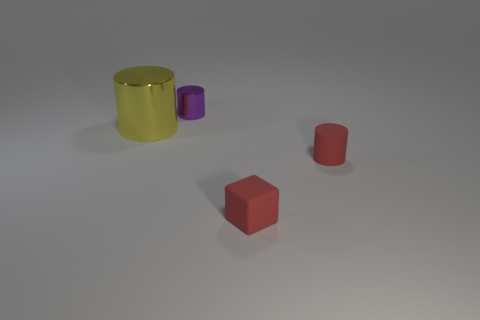Subtract all red rubber cylinders. How many cylinders are left? 2 Add 3 yellow metallic cylinders. How many objects exist? 7 Subtract 1 cylinders. How many cylinders are left? 2 Subtract all purple cylinders. How many cylinders are left? 2 Subtract 0 yellow blocks. How many objects are left? 4 Subtract all cylinders. How many objects are left? 1 Subtract all cyan cylinders. Subtract all green cubes. How many cylinders are left? 3 Subtract all tiny purple shiny cylinders. Subtract all large yellow shiny things. How many objects are left? 2 Add 1 tiny purple shiny cylinders. How many tiny purple shiny cylinders are left? 2 Add 3 yellow things. How many yellow things exist? 4 